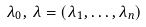<formula> <loc_0><loc_0><loc_500><loc_500>\lambda _ { 0 } , \, { \lambda } = ( \lambda _ { 1 } , \dots , \lambda _ { n } )</formula> 